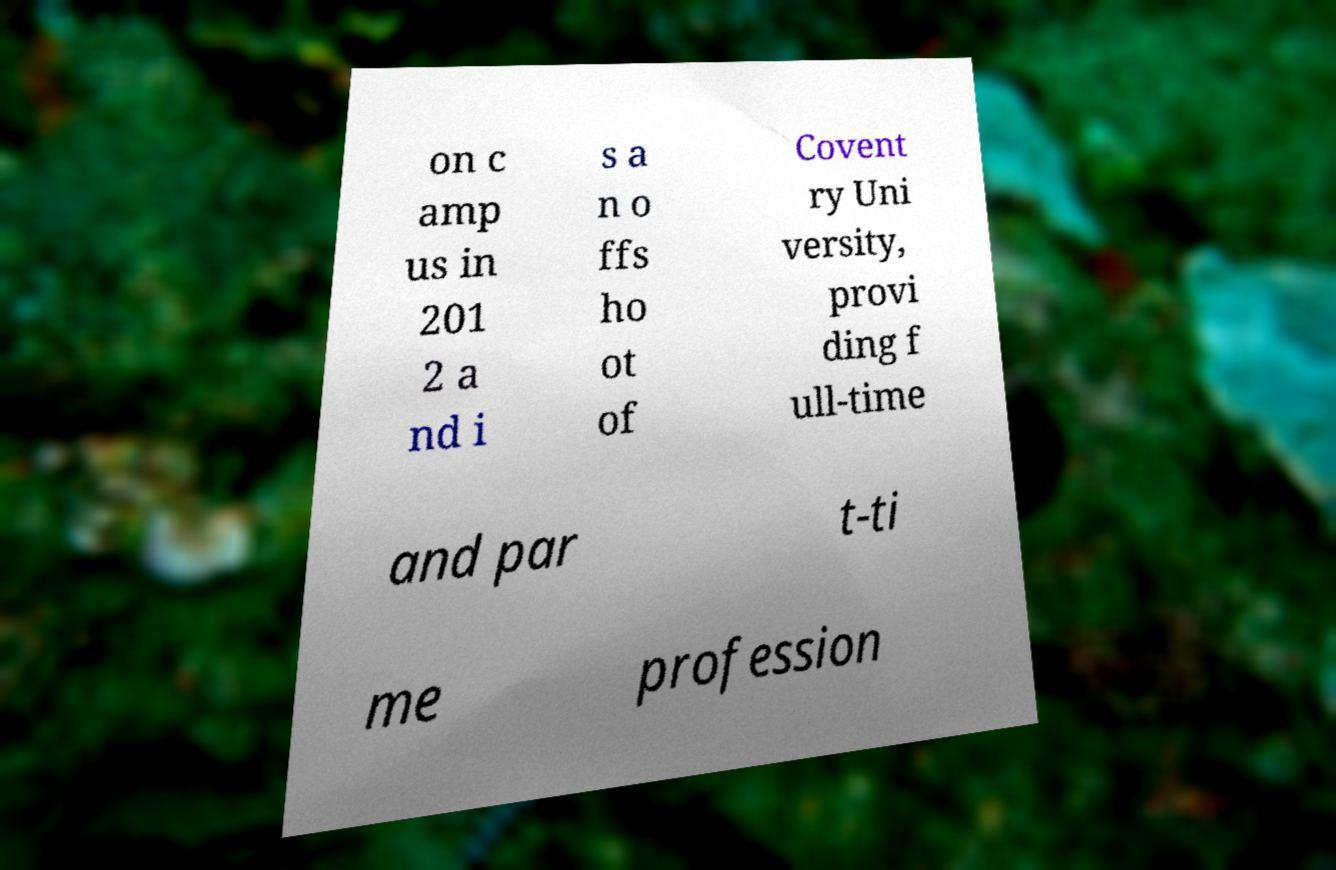Can you read and provide the text displayed in the image?This photo seems to have some interesting text. Can you extract and type it out for me? on c amp us in 201 2 a nd i s a n o ffs ho ot of Covent ry Uni versity, provi ding f ull-time and par t-ti me profession 